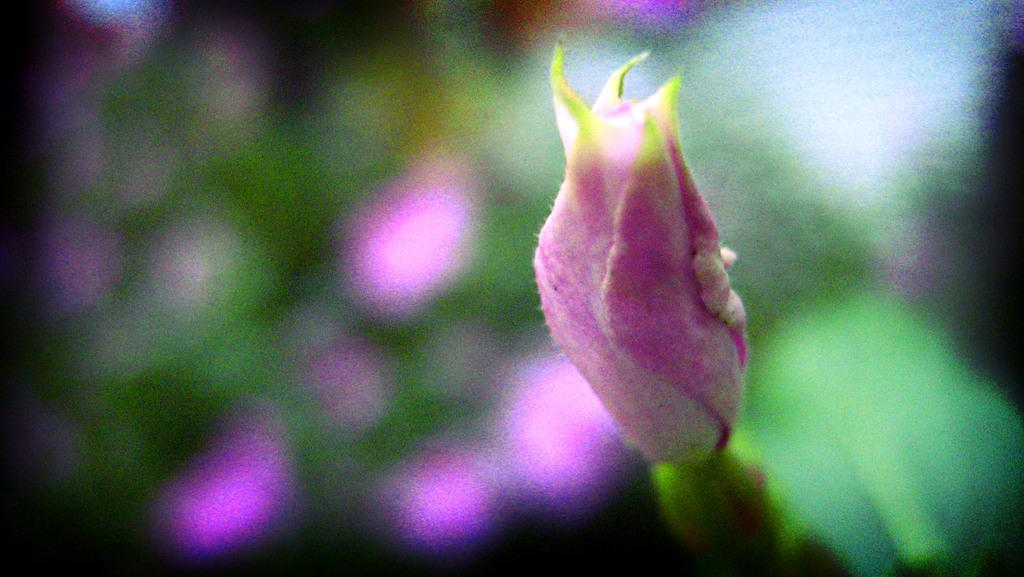What is the main subject in the foreground of the picture? There is a flower in the foreground of the picture. How would you describe the background of the image? The background of the image is blurred. How many plants are whispering quietly in the background of the image? There are no plants or whispering in the background of the image. 